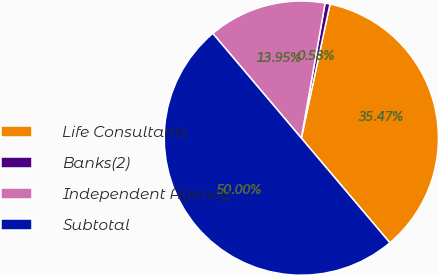Convert chart. <chart><loc_0><loc_0><loc_500><loc_500><pie_chart><fcel>Life Consultants<fcel>Banks(2)<fcel>Independent Agency<fcel>Subtotal<nl><fcel>35.47%<fcel>0.58%<fcel>13.95%<fcel>50.0%<nl></chart> 